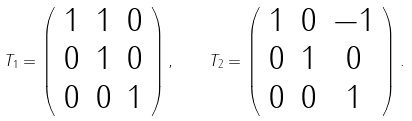Convert formula to latex. <formula><loc_0><loc_0><loc_500><loc_500>T _ { 1 } = \left ( \begin{array} { c c c } 1 & 1 & 0 \\ 0 & 1 & 0 \\ 0 & 0 & 1 \end{array} \right ) , \quad T _ { 2 } = \left ( \begin{array} { c c c } 1 & 0 & - 1 \\ 0 & 1 & 0 \\ 0 & 0 & 1 \end{array} \right ) .</formula> 